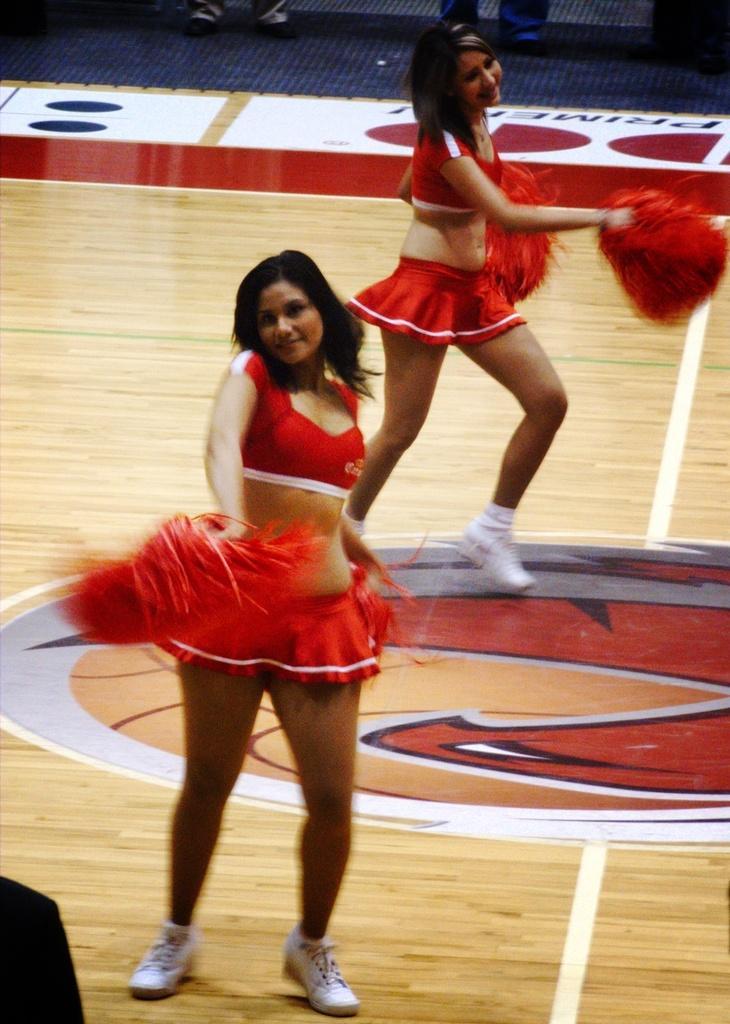Can you describe this image briefly? In this picture I can observe two women dancing on the floor. They are wearing red color dresses. The floor is in cream color. 